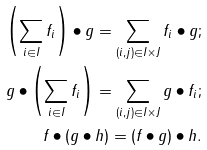Convert formula to latex. <formula><loc_0><loc_0><loc_500><loc_500>\left ( \sum _ { i \in I } f _ { i } \right ) \bullet g = \sum _ { ( i , j ) \in I \times J } f _ { i } \bullet g ; \\ g \bullet \left ( \sum _ { i \in I } f _ { i } \right ) = \sum _ { ( i , j ) \in I \times J } g \bullet f _ { i } ; \\ f \bullet ( g \bullet h ) = ( f \bullet g ) \bullet h .</formula> 